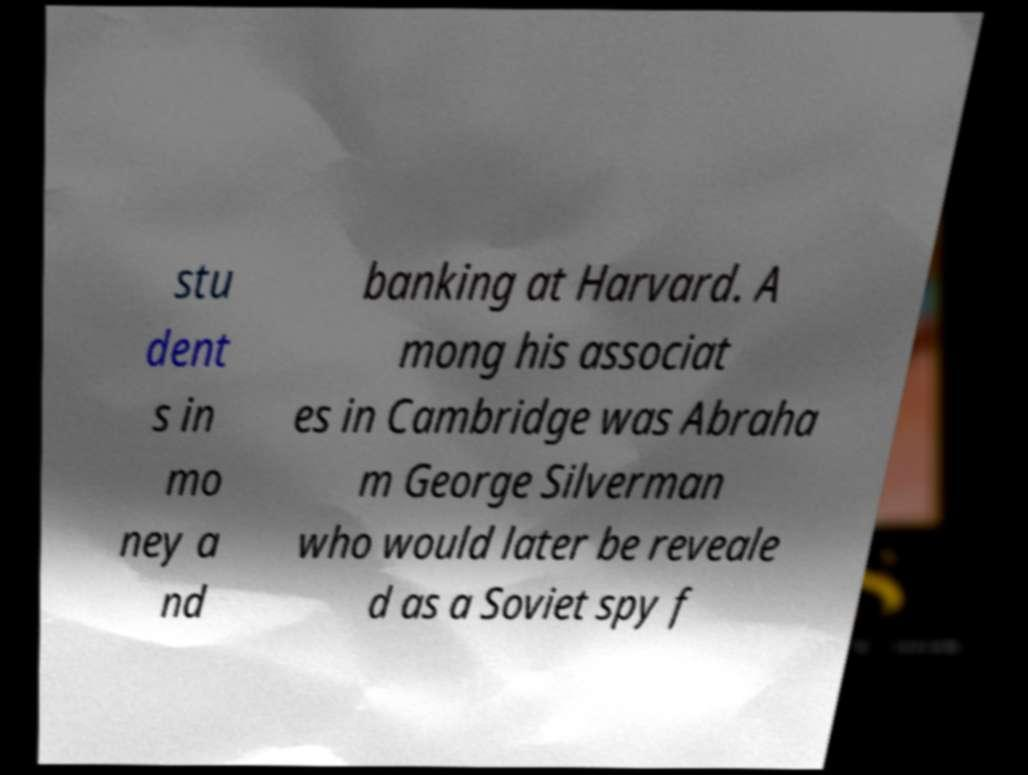Please read and relay the text visible in this image. What does it say? stu dent s in mo ney a nd banking at Harvard. A mong his associat es in Cambridge was Abraha m George Silverman who would later be reveale d as a Soviet spy f 